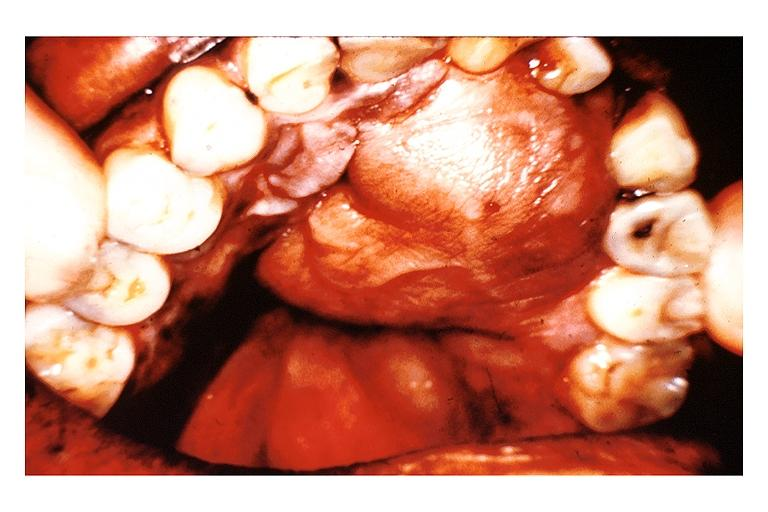s oral present?
Answer the question using a single word or phrase. Yes 